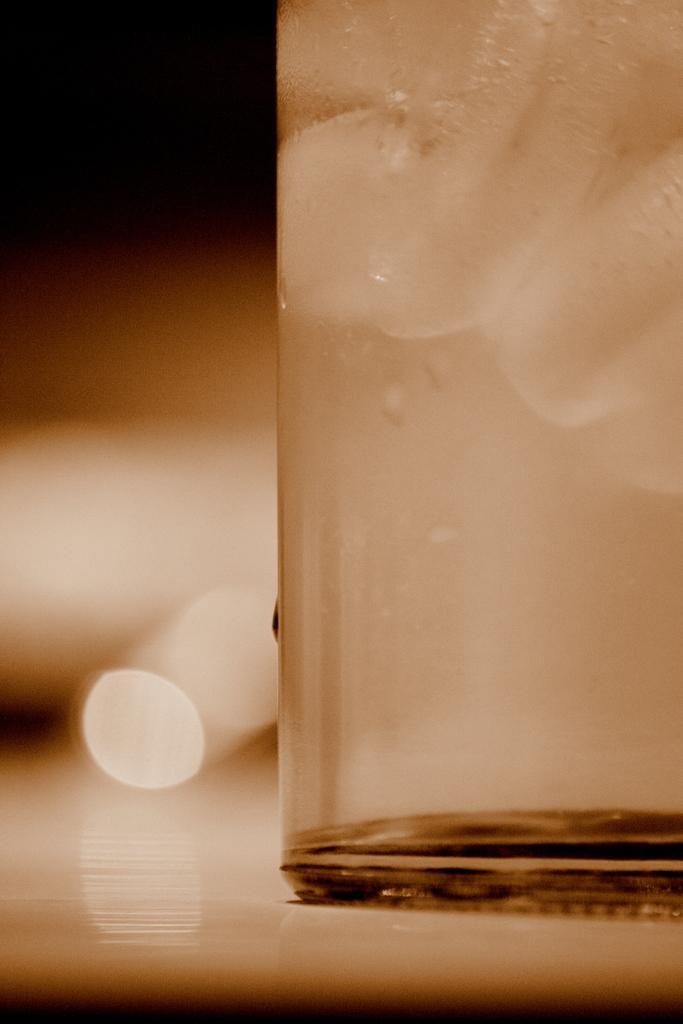Could you give a brief overview of what you see in this image? In the foreground of this image, there is a glass on the right side and few droplets of water on it which is placed on a white surface and the background image is blurred. 